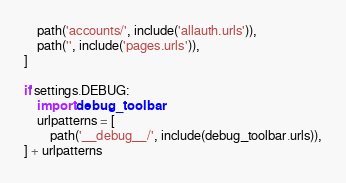Convert code to text. <code><loc_0><loc_0><loc_500><loc_500><_Python_>    path('accounts/', include('allauth.urls')),
    path('', include('pages.urls')),
]

if settings.DEBUG:
    import debug_toolbar
    urlpatterns = [
        path('__debug__/', include(debug_toolbar.urls)),
] + urlpatterns
</code> 